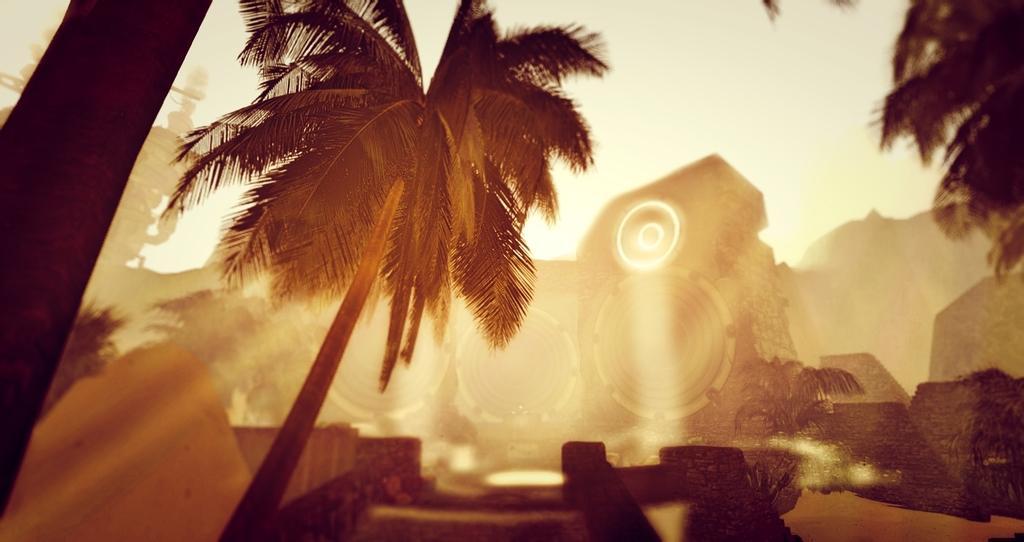Describe this image in one or two sentences. In this picture I can see there are few trees, building in the backdrop and the sky is clear. This is a black and white image. 